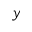<formula> <loc_0><loc_0><loc_500><loc_500>y</formula> 